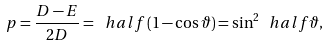<formula> <loc_0><loc_0><loc_500><loc_500>p = \frac { D - E } { 2 D } = \ h a l f \left ( 1 - \cos \vartheta \right ) = \sin ^ { 2 } \ h a l f \vartheta ,</formula> 